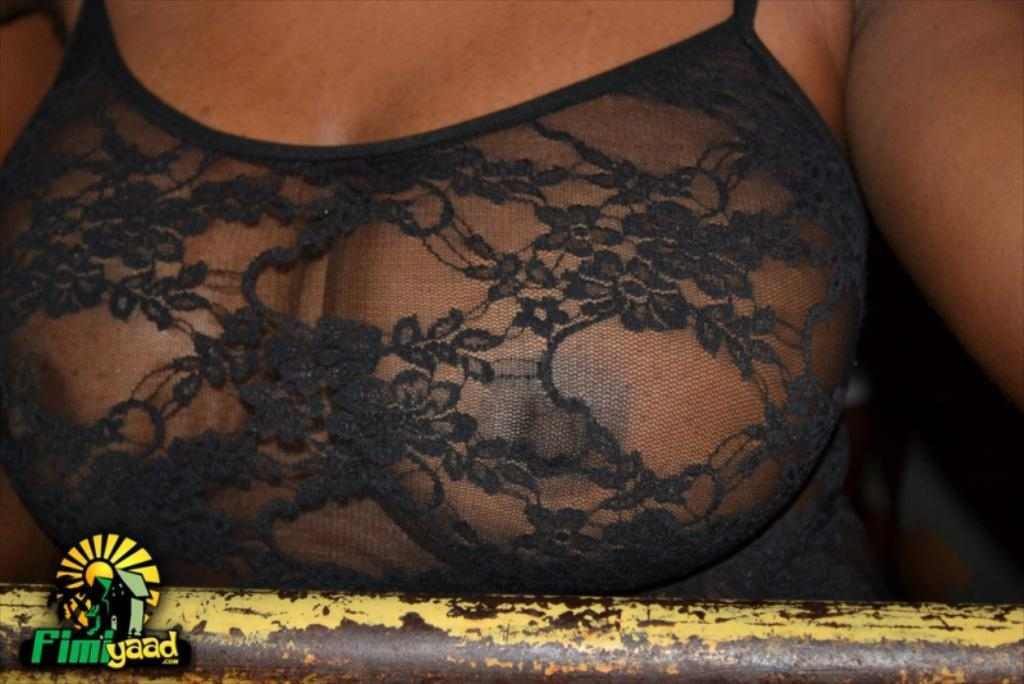What part of a woman's body is visible in the image? There is a woman's breast visible in the image. What theory does the father in the image propose about the bomb? There is no father, theory, or bomb present in the image. The image only features a woman's breast. 